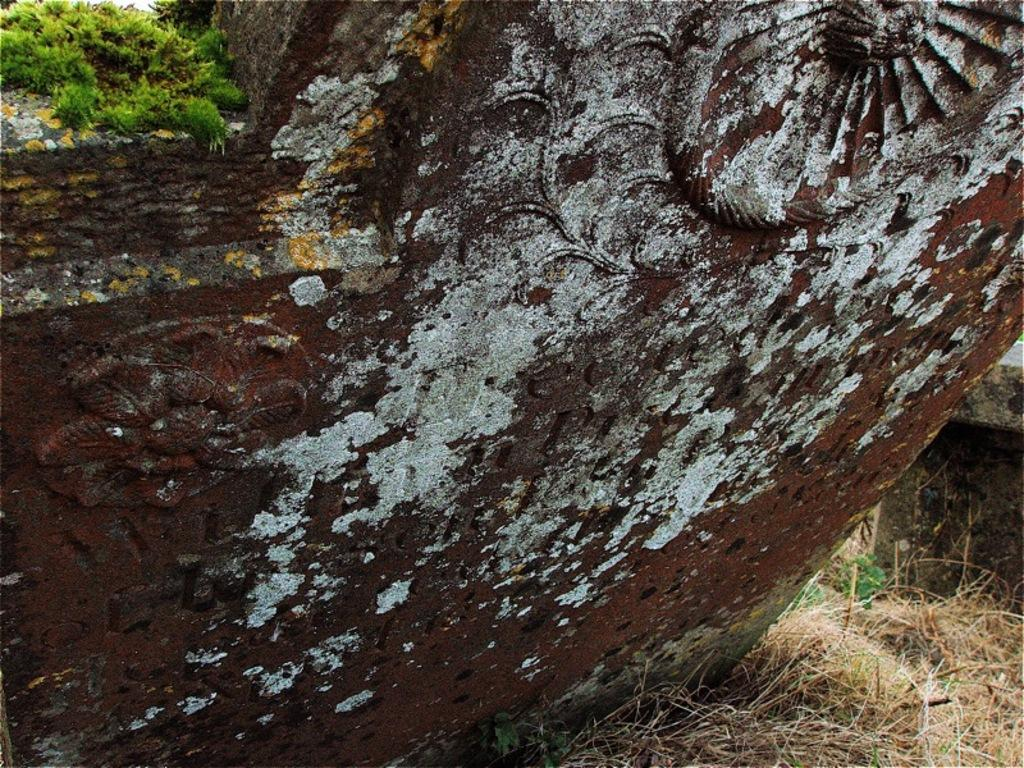What type of object is made of metal in the image? The facts do not specify the type of metal object in the image. What surrounds the metal object in the image? Grass is present on both sides of the metal object. What colors can be seen in the grass in the image? The grass is in green and brown colors. What type of whip can be seen in the image? There is no whip present in the image. How does the jelly interact with the metal object in the image? There is no jelly present in the image. 